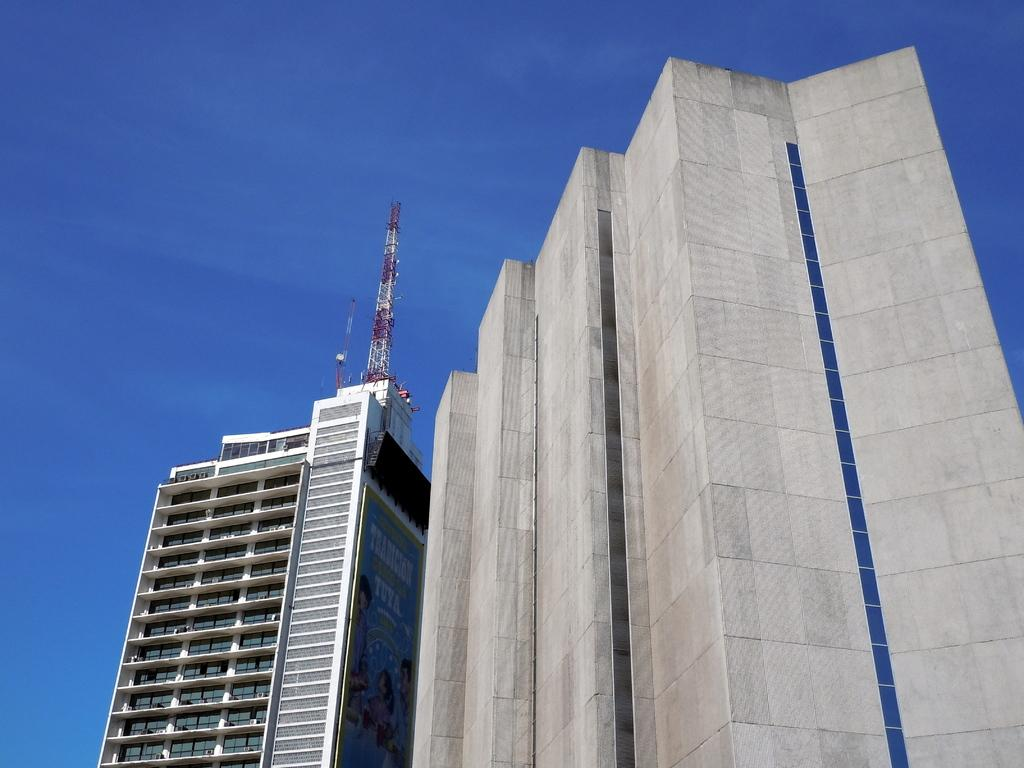What type of structure is visible in the image? There is a building in the image. What is located on top of the building? There is an antenna on top of the building. What is the condition of the sky in the image? The sky is clear in the image. Where is the father located in the image? There is no father present in the image; it only features a building and an antenna. How many beds can be seen in the image? There are no beds present in the image. 